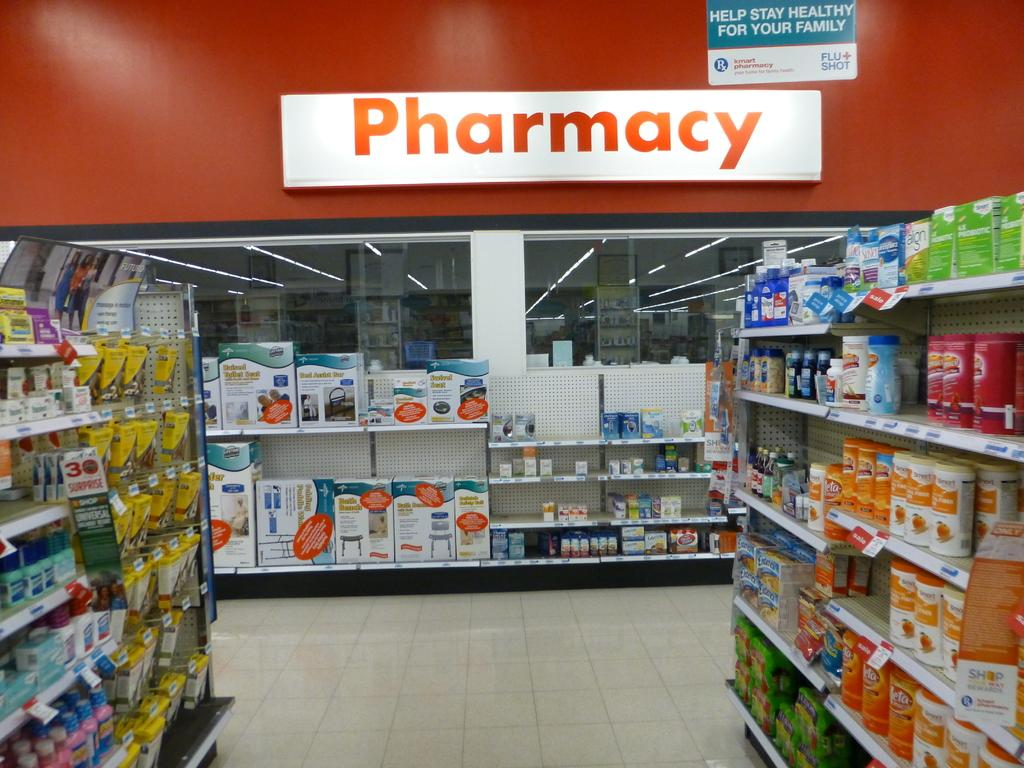<image>
Render a clear and concise summary of the photo. The supplement isle in a K mart pharmacy. 